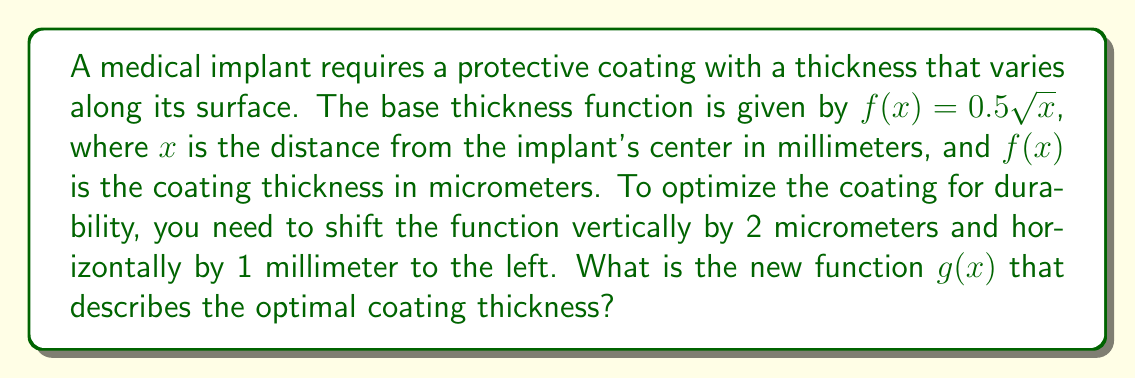Teach me how to tackle this problem. To determine the new function $g(x)$, we need to apply both a vertical and a horizontal shift to the original function $f(x)$. Let's break this down step-by-step:

1) The original function is $f(x) = 0.5\sqrt{x}$

2) For a vertical shift of 2 micrometers upward, we add 2 to the function:
   $f(x) + 2$

3) For a horizontal shift of 1 millimeter to the left, we replace $x$ with $(x + 1)$:
   $0.5\sqrt{x + 1} + 2$

4) Combining these transformations, we get the new function $g(x)$:
   $g(x) = 0.5\sqrt{x + 1} + 2$

This new function $g(x)$ represents the optimal coating thickness for the medical implant, taking into account the required vertical and horizontal shifts.
Answer: $g(x) = 0.5\sqrt{x + 1} + 2$ 